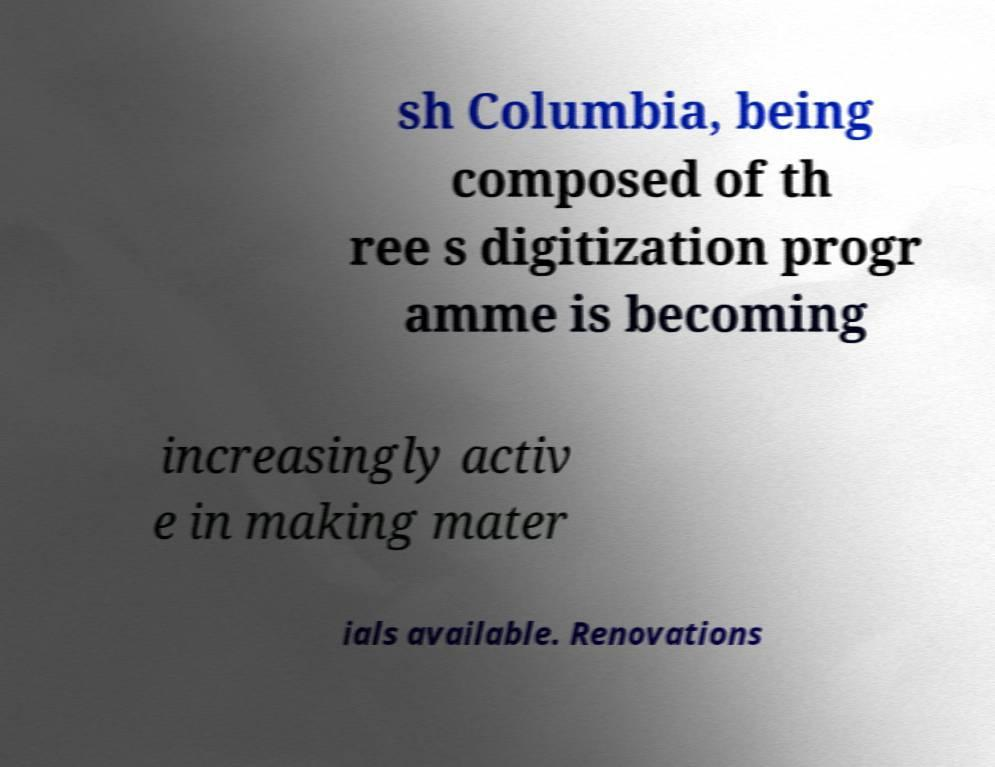Can you accurately transcribe the text from the provided image for me? sh Columbia, being composed of th ree s digitization progr amme is becoming increasingly activ e in making mater ials available. Renovations 